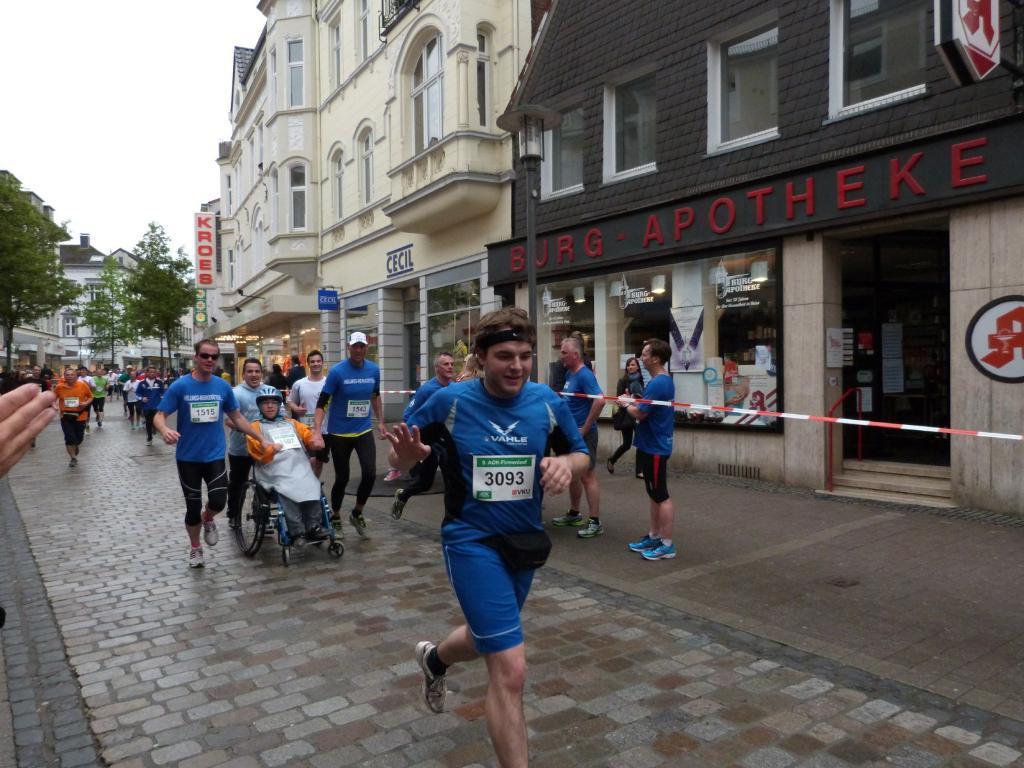In one or two sentences, can you explain what this image depicts? Here in this picture we can see some people are running on the road over there and in the middle we can see some people carrying a person, who is sitting in the wheel chair with helmet on him over there and beside them we can see some people standing over there and we can also see stores and buildings present all over there and we can see its doors and windows on it and we can also see hoardings present and we can see trees present over there. 